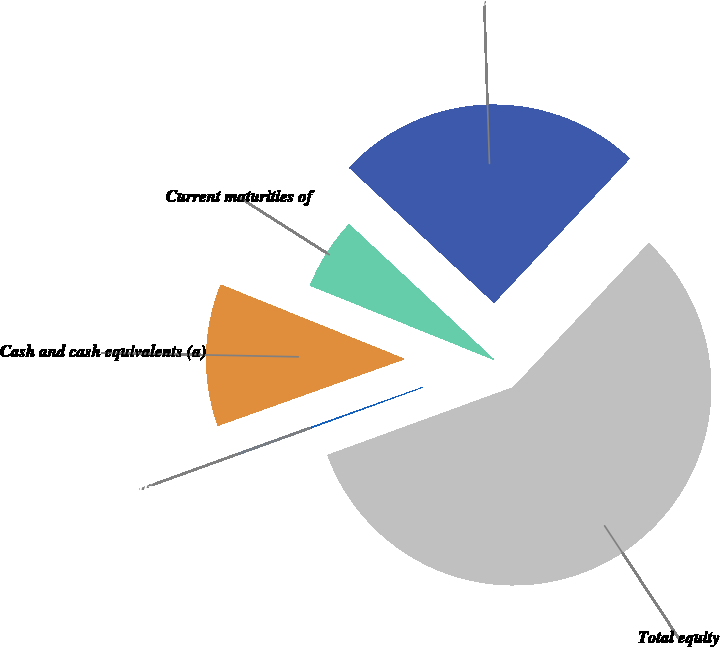Convert chart to OTSL. <chart><loc_0><loc_0><loc_500><loc_500><pie_chart><fcel>Cash and cash equivalents (a)<fcel>Current maturities of<fcel>Total debt (b)<fcel>Total equity<fcel>Debt to capitalization ratio<nl><fcel>11.57%<fcel>5.84%<fcel>25.06%<fcel>57.41%<fcel>0.11%<nl></chart> 